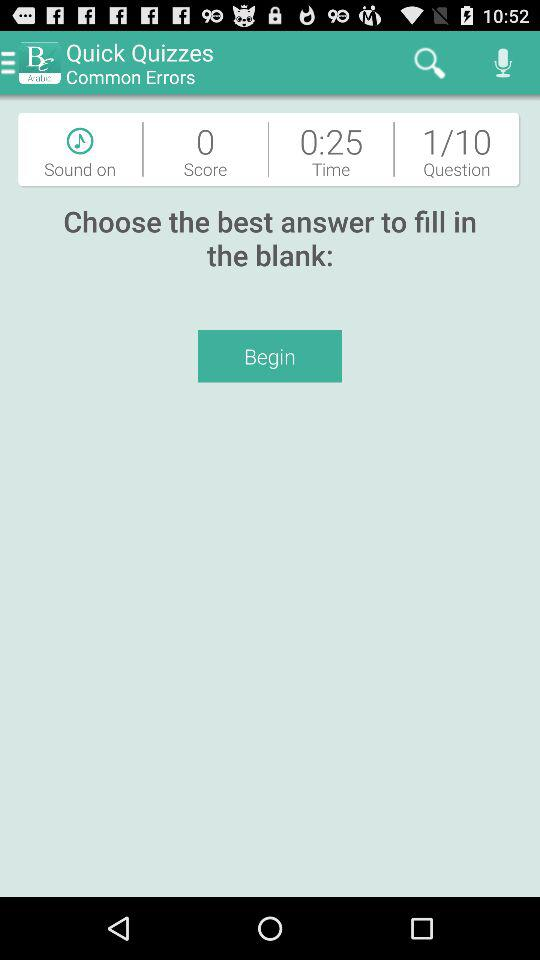How many questions are there in this quiz?
Answer the question using a single word or phrase. 10 